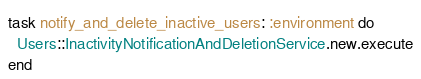<code> <loc_0><loc_0><loc_500><loc_500><_Ruby_>task notify_and_delete_inactive_users: :environment do
  Users::InactivityNotificationAndDeletionService.new.execute
end

</code> 